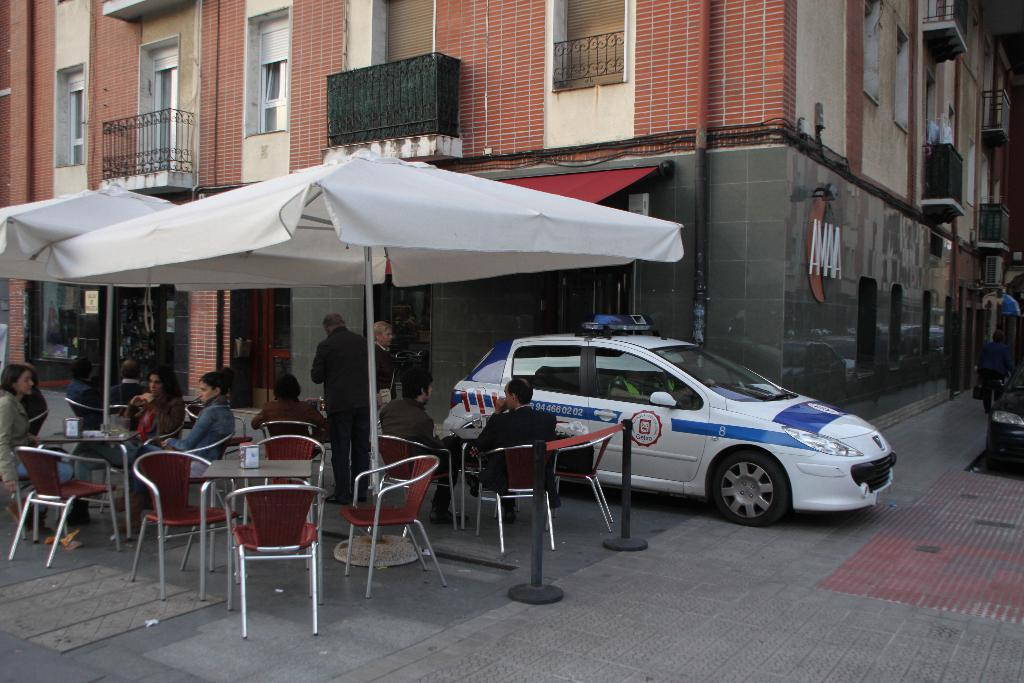What are the people in the image doing? The people in the image are sitting on chairs. What object is present to provide shade or shelter in the image? There is an umbrella in the image. What can be seen in the distance behind the people? There is a building visible in the background of the image. What type of wing is attached to the hen in the image? There is no hen or wing present in the image. 